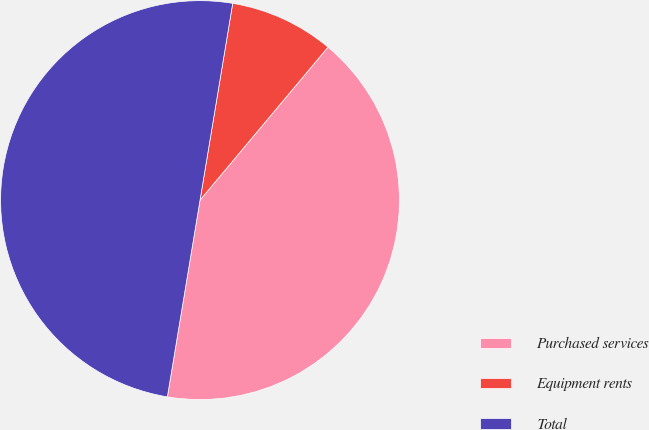Convert chart. <chart><loc_0><loc_0><loc_500><loc_500><pie_chart><fcel>Purchased services<fcel>Equipment rents<fcel>Total<nl><fcel>41.53%<fcel>8.47%<fcel>50.0%<nl></chart> 